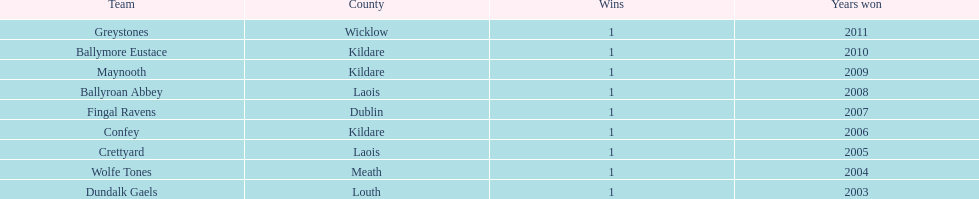What is the number of wins for confey 1. 